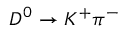Convert formula to latex. <formula><loc_0><loc_0><loc_500><loc_500>D ^ { 0 } \to K ^ { + } \pi ^ { - }</formula> 